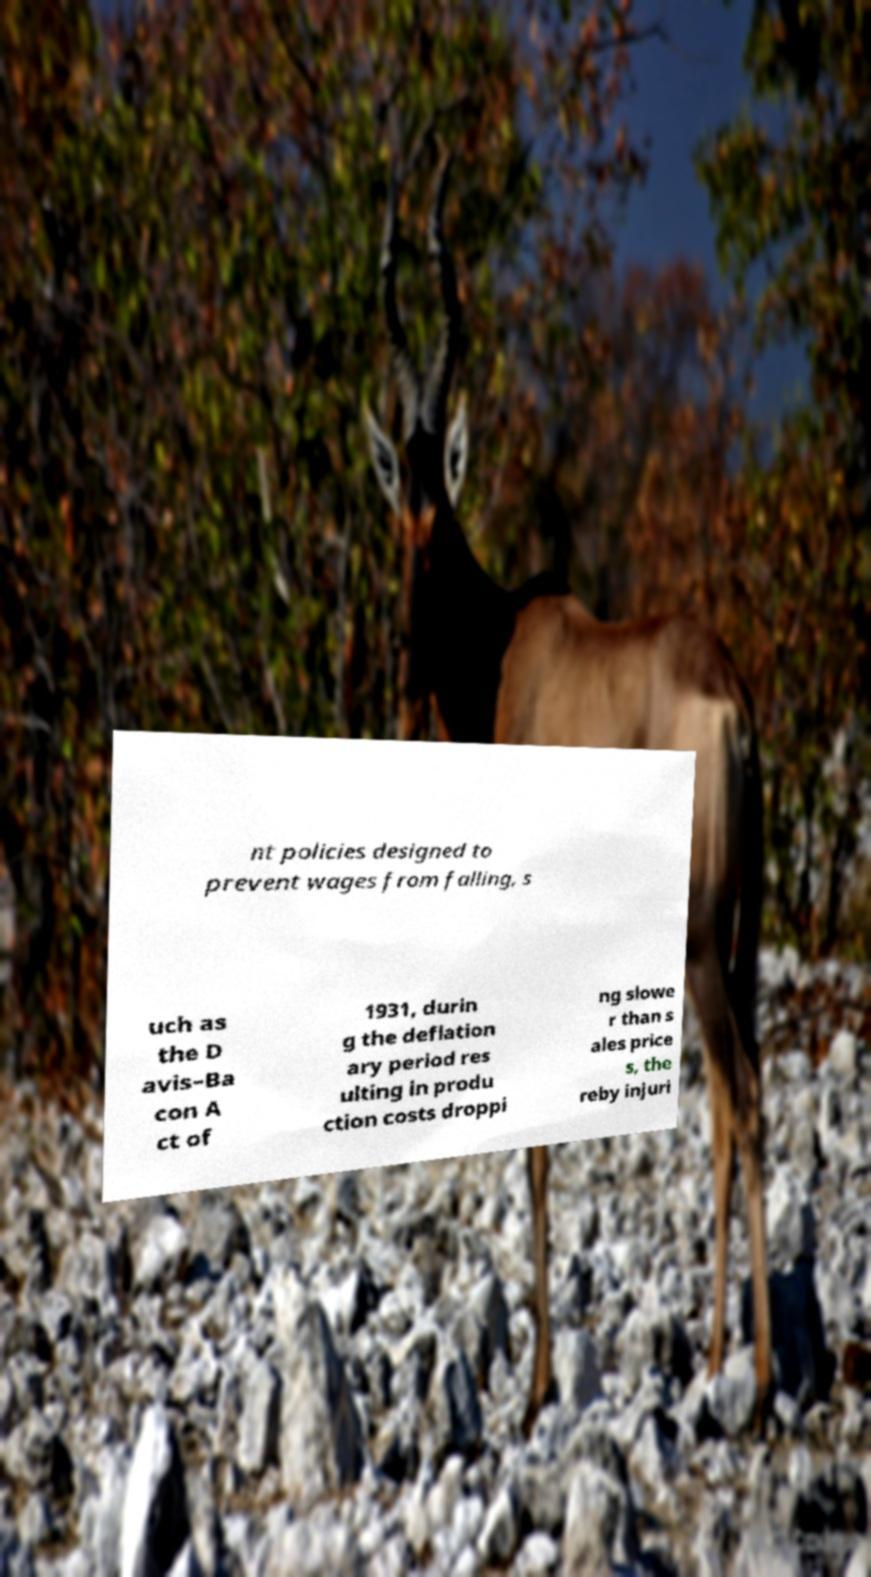There's text embedded in this image that I need extracted. Can you transcribe it verbatim? nt policies designed to prevent wages from falling, s uch as the D avis–Ba con A ct of 1931, durin g the deflation ary period res ulting in produ ction costs droppi ng slowe r than s ales price s, the reby injuri 